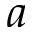<formula> <loc_0><loc_0><loc_500><loc_500>a</formula> 